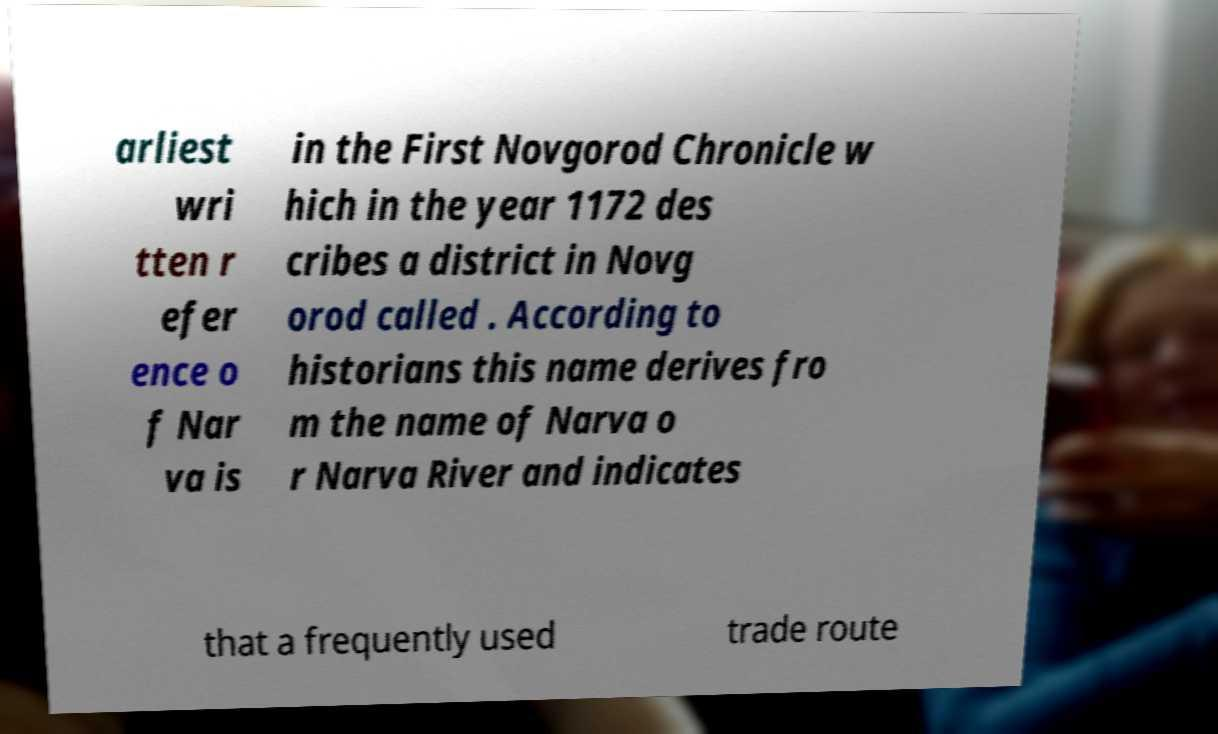Please read and relay the text visible in this image. What does it say? arliest wri tten r efer ence o f Nar va is in the First Novgorod Chronicle w hich in the year 1172 des cribes a district in Novg orod called . According to historians this name derives fro m the name of Narva o r Narva River and indicates that a frequently used trade route 